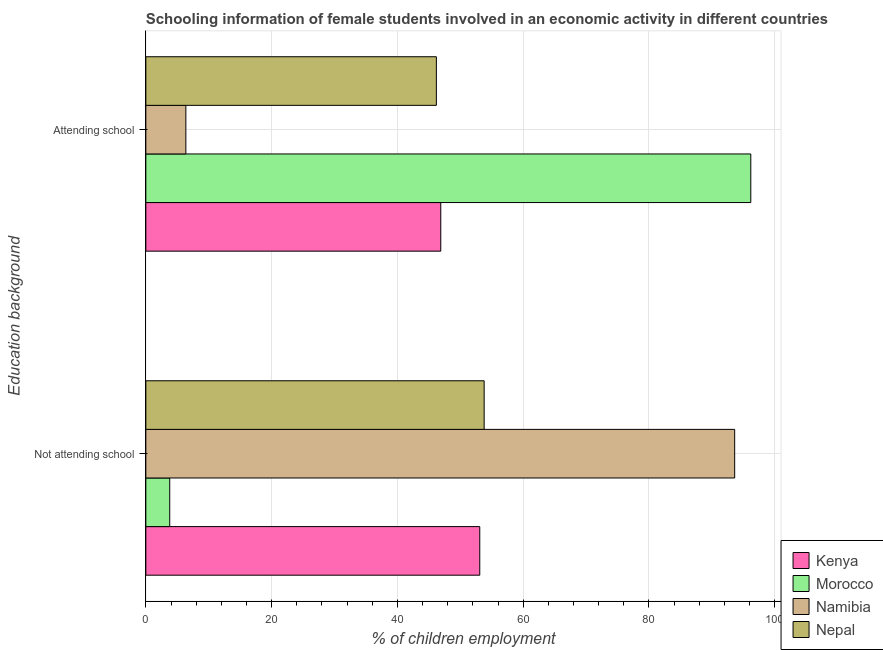Are the number of bars per tick equal to the number of legend labels?
Make the answer very short. Yes. Are the number of bars on each tick of the Y-axis equal?
Make the answer very short. Yes. How many bars are there on the 2nd tick from the top?
Make the answer very short. 4. What is the label of the 1st group of bars from the top?
Ensure brevity in your answer.  Attending school. What is the percentage of employed females who are not attending school in Kenya?
Your answer should be compact. 53.1. Across all countries, what is the maximum percentage of employed females who are not attending school?
Make the answer very short. 93.64. In which country was the percentage of employed females who are not attending school maximum?
Make the answer very short. Namibia. In which country was the percentage of employed females who are not attending school minimum?
Your answer should be very brief. Morocco. What is the total percentage of employed females who are attending school in the graph?
Your response must be concise. 195.66. What is the difference between the percentage of employed females who are not attending school in Nepal and that in Namibia?
Keep it short and to the point. -39.84. What is the difference between the percentage of employed females who are attending school in Morocco and the percentage of employed females who are not attending school in Kenya?
Offer a terse response. 43.1. What is the average percentage of employed females who are not attending school per country?
Keep it short and to the point. 51.08. What is the difference between the percentage of employed females who are not attending school and percentage of employed females who are attending school in Morocco?
Your response must be concise. -92.4. What is the ratio of the percentage of employed females who are not attending school in Morocco to that in Namibia?
Your answer should be compact. 0.04. Is the percentage of employed females who are attending school in Kenya less than that in Nepal?
Offer a very short reply. No. In how many countries, is the percentage of employed females who are attending school greater than the average percentage of employed females who are attending school taken over all countries?
Offer a terse response. 1. What does the 4th bar from the top in Attending school represents?
Provide a succinct answer. Kenya. What does the 3rd bar from the bottom in Not attending school represents?
Provide a succinct answer. Namibia. Are all the bars in the graph horizontal?
Offer a terse response. Yes. Where does the legend appear in the graph?
Provide a succinct answer. Bottom right. How many legend labels are there?
Ensure brevity in your answer.  4. How are the legend labels stacked?
Keep it short and to the point. Vertical. What is the title of the graph?
Keep it short and to the point. Schooling information of female students involved in an economic activity in different countries. Does "Algeria" appear as one of the legend labels in the graph?
Your answer should be compact. No. What is the label or title of the X-axis?
Give a very brief answer. % of children employment. What is the label or title of the Y-axis?
Ensure brevity in your answer.  Education background. What is the % of children employment in Kenya in Not attending school?
Make the answer very short. 53.1. What is the % of children employment of Namibia in Not attending school?
Ensure brevity in your answer.  93.64. What is the % of children employment in Nepal in Not attending school?
Provide a succinct answer. 53.8. What is the % of children employment in Kenya in Attending school?
Provide a succinct answer. 46.9. What is the % of children employment in Morocco in Attending school?
Make the answer very short. 96.2. What is the % of children employment of Namibia in Attending school?
Make the answer very short. 6.36. What is the % of children employment of Nepal in Attending school?
Provide a short and direct response. 46.2. Across all Education background, what is the maximum % of children employment in Kenya?
Your answer should be compact. 53.1. Across all Education background, what is the maximum % of children employment of Morocco?
Provide a succinct answer. 96.2. Across all Education background, what is the maximum % of children employment in Namibia?
Your answer should be compact. 93.64. Across all Education background, what is the maximum % of children employment of Nepal?
Give a very brief answer. 53.8. Across all Education background, what is the minimum % of children employment of Kenya?
Ensure brevity in your answer.  46.9. Across all Education background, what is the minimum % of children employment of Namibia?
Your response must be concise. 6.36. Across all Education background, what is the minimum % of children employment of Nepal?
Your response must be concise. 46.2. What is the difference between the % of children employment of Kenya in Not attending school and that in Attending school?
Ensure brevity in your answer.  6.2. What is the difference between the % of children employment of Morocco in Not attending school and that in Attending school?
Make the answer very short. -92.4. What is the difference between the % of children employment in Namibia in Not attending school and that in Attending school?
Give a very brief answer. 87.27. What is the difference between the % of children employment of Kenya in Not attending school and the % of children employment of Morocco in Attending school?
Your answer should be compact. -43.1. What is the difference between the % of children employment of Kenya in Not attending school and the % of children employment of Namibia in Attending school?
Offer a terse response. 46.74. What is the difference between the % of children employment of Morocco in Not attending school and the % of children employment of Namibia in Attending school?
Ensure brevity in your answer.  -2.56. What is the difference between the % of children employment of Morocco in Not attending school and the % of children employment of Nepal in Attending school?
Make the answer very short. -42.4. What is the difference between the % of children employment of Namibia in Not attending school and the % of children employment of Nepal in Attending school?
Offer a very short reply. 47.44. What is the average % of children employment in Kenya per Education background?
Make the answer very short. 50. What is the average % of children employment of Namibia per Education background?
Offer a very short reply. 50. What is the average % of children employment in Nepal per Education background?
Offer a terse response. 50. What is the difference between the % of children employment of Kenya and % of children employment of Morocco in Not attending school?
Provide a succinct answer. 49.3. What is the difference between the % of children employment in Kenya and % of children employment in Namibia in Not attending school?
Your answer should be very brief. -40.54. What is the difference between the % of children employment in Morocco and % of children employment in Namibia in Not attending school?
Keep it short and to the point. -89.84. What is the difference between the % of children employment in Morocco and % of children employment in Nepal in Not attending school?
Your answer should be compact. -50. What is the difference between the % of children employment in Namibia and % of children employment in Nepal in Not attending school?
Your answer should be very brief. 39.84. What is the difference between the % of children employment of Kenya and % of children employment of Morocco in Attending school?
Provide a short and direct response. -49.3. What is the difference between the % of children employment of Kenya and % of children employment of Namibia in Attending school?
Give a very brief answer. 40.54. What is the difference between the % of children employment in Kenya and % of children employment in Nepal in Attending school?
Provide a short and direct response. 0.7. What is the difference between the % of children employment of Morocco and % of children employment of Namibia in Attending school?
Provide a succinct answer. 89.84. What is the difference between the % of children employment of Namibia and % of children employment of Nepal in Attending school?
Your response must be concise. -39.84. What is the ratio of the % of children employment of Kenya in Not attending school to that in Attending school?
Provide a short and direct response. 1.13. What is the ratio of the % of children employment of Morocco in Not attending school to that in Attending school?
Your answer should be compact. 0.04. What is the ratio of the % of children employment in Namibia in Not attending school to that in Attending school?
Make the answer very short. 14.72. What is the ratio of the % of children employment of Nepal in Not attending school to that in Attending school?
Provide a short and direct response. 1.16. What is the difference between the highest and the second highest % of children employment of Kenya?
Make the answer very short. 6.2. What is the difference between the highest and the second highest % of children employment in Morocco?
Offer a very short reply. 92.4. What is the difference between the highest and the second highest % of children employment of Namibia?
Make the answer very short. 87.27. What is the difference between the highest and the second highest % of children employment of Nepal?
Keep it short and to the point. 7.6. What is the difference between the highest and the lowest % of children employment in Kenya?
Your response must be concise. 6.2. What is the difference between the highest and the lowest % of children employment in Morocco?
Offer a terse response. 92.4. What is the difference between the highest and the lowest % of children employment of Namibia?
Ensure brevity in your answer.  87.27. What is the difference between the highest and the lowest % of children employment of Nepal?
Provide a short and direct response. 7.6. 